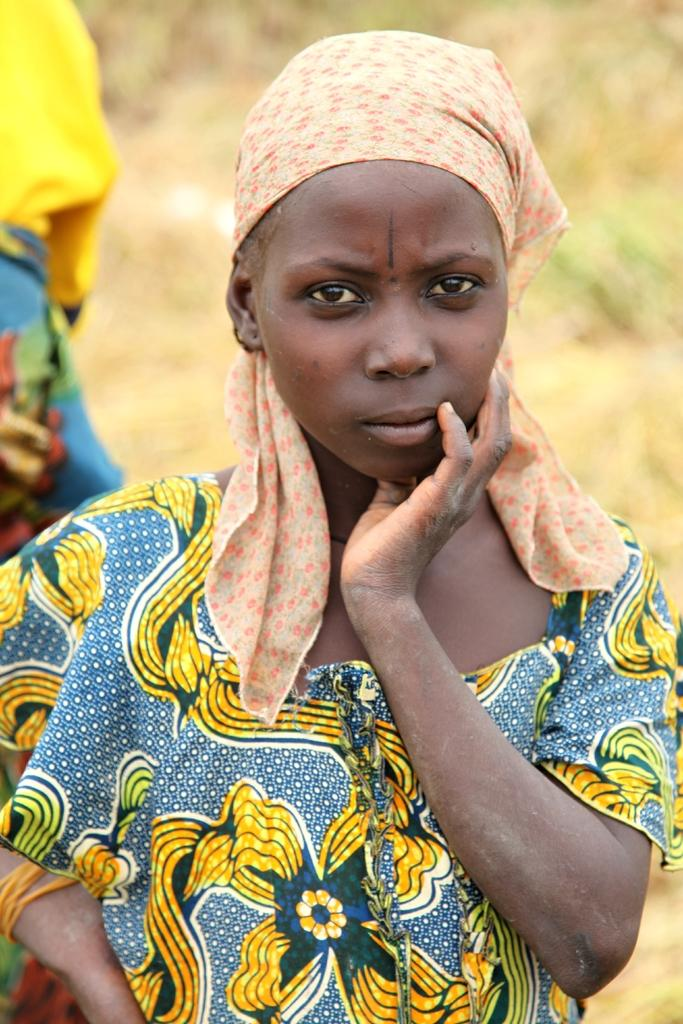What is present in the image? There is a woman in the image. Can you describe the woman's attire? The woman is wearing clothes. What type of grip does the woman have on the wren in the image? There is no wren present in the image, and therefore no grip can be observed. 